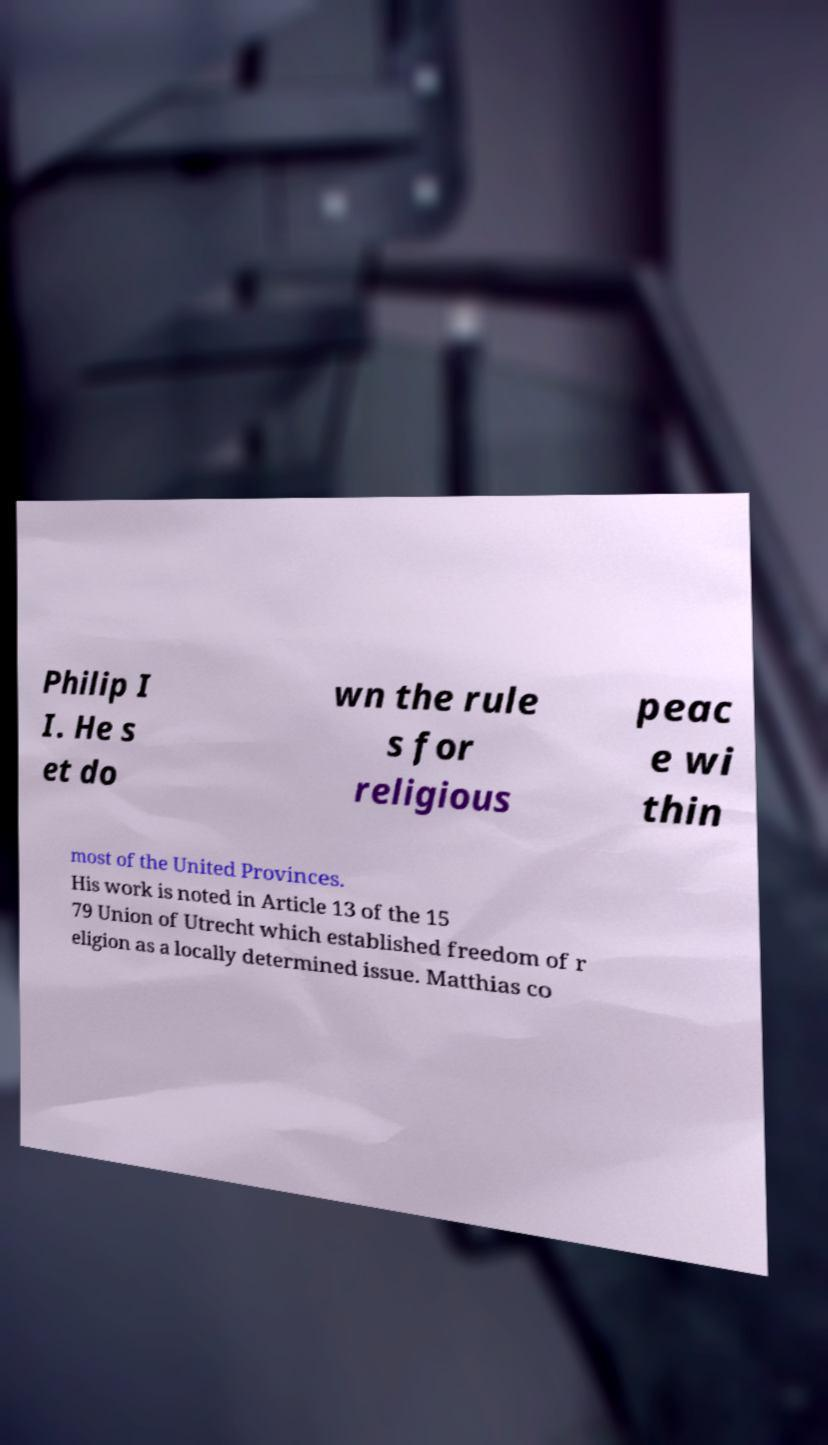Please identify and transcribe the text found in this image. Philip I I. He s et do wn the rule s for religious peac e wi thin most of the United Provinces. His work is noted in Article 13 of the 15 79 Union of Utrecht which established freedom of r eligion as a locally determined issue. Matthias co 